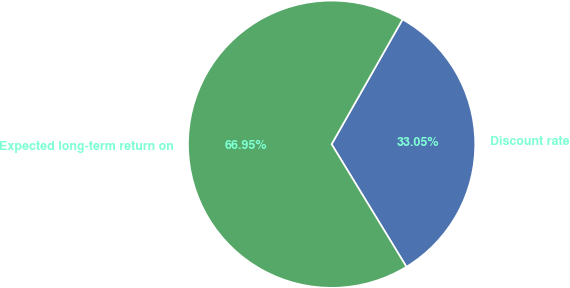Convert chart. <chart><loc_0><loc_0><loc_500><loc_500><pie_chart><fcel>Discount rate<fcel>Expected long-term return on<nl><fcel>33.05%<fcel>66.95%<nl></chart> 